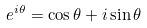Convert formula to latex. <formula><loc_0><loc_0><loc_500><loc_500>e ^ { i \theta } = \cos \theta + i \sin \theta</formula> 